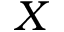<formula> <loc_0><loc_0><loc_500><loc_500>X</formula> 